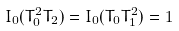Convert formula to latex. <formula><loc_0><loc_0><loc_500><loc_500>I _ { 0 } ( T _ { 0 } ^ { 2 } T _ { 2 } ) = I _ { 0 } ( T _ { 0 } T _ { 1 } ^ { 2 } ) = 1</formula> 